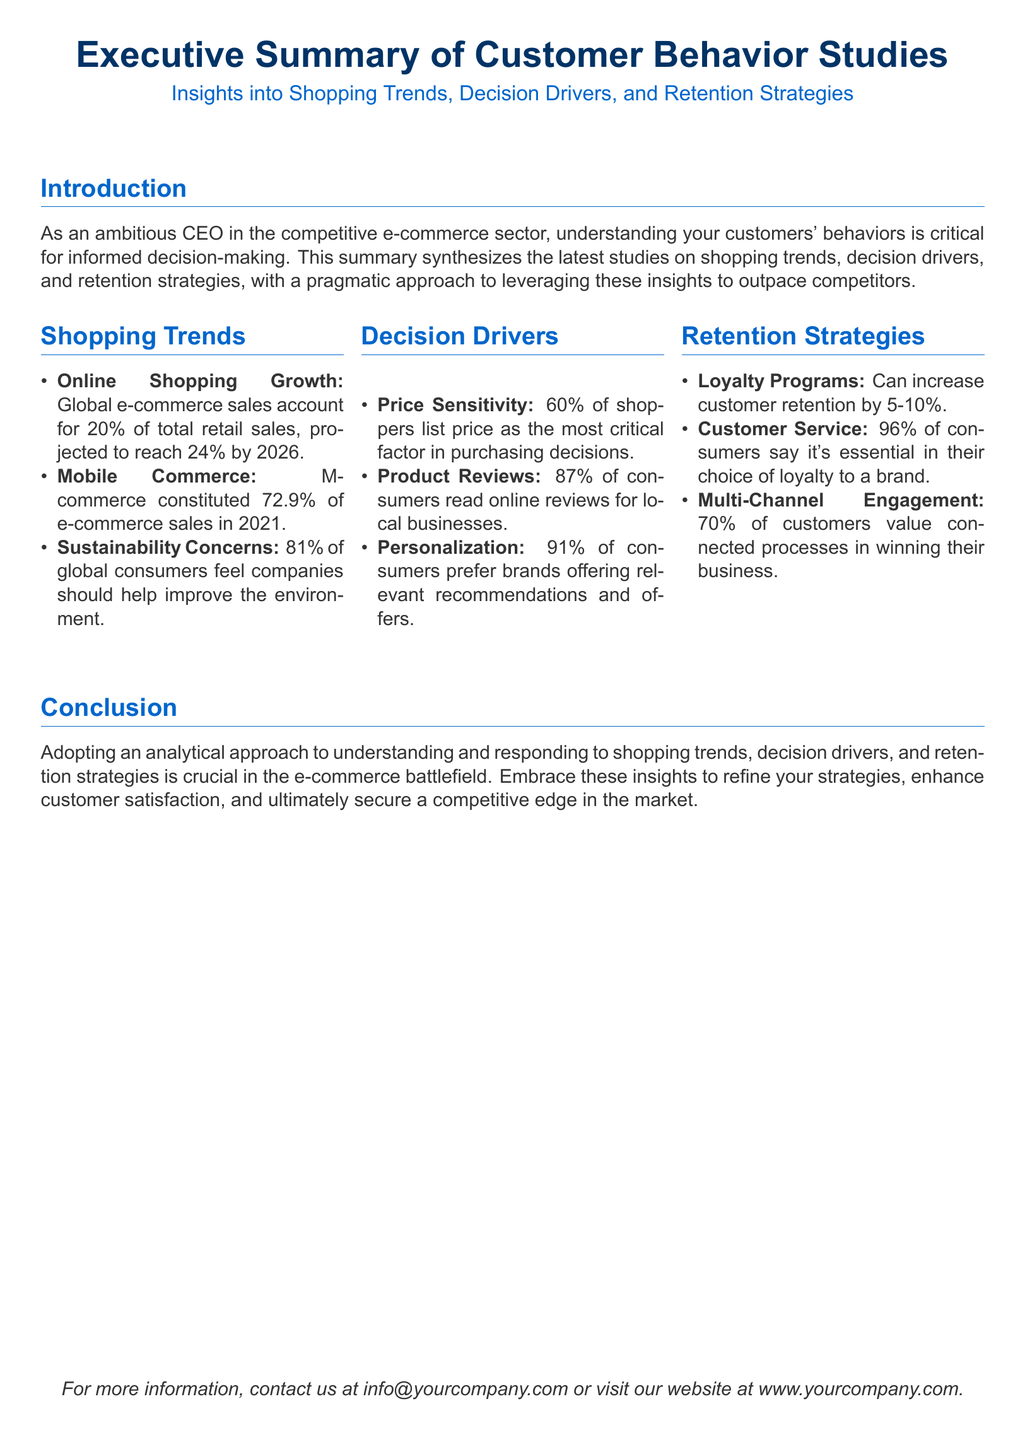What percentage of global consumers feel companies should help improve the environment? The document states that 81% of global consumers believe that companies should assist in environmental improvement.
Answer: 81% What is the projected percentage of global e-commerce sales by 2026? According to the document, global e-commerce sales are projected to reach 24% of total retail sales by 2026.
Answer: 24% What is the most critical factor in purchasing decisions for 60% of shoppers? The summary highlights that price is the most critical factor in purchasing decisions for 60% of shoppers.
Answer: Price What percentage of consumers prefer brands offering relevant recommendations? The document mentions that 91% of consumers prefer brands that provide tailored recommendations and offers.
Answer: 91% How much can loyalty programs increase customer retention? The document states that loyalty programs can increase customer retention by 5-10%.
Answer: 5-10% What is essential in the choice of loyalty to a brand for 96% of consumers? Customer service is noted as essential in the loyalty choice for 96% of consumers.
Answer: Customer service What shopping trend constituted 72.9% of e-commerce sales in 2021? The document states that mobile commerce comprised 72.9% of e-commerce sales in 2021.
Answer: Mobile commerce What is one of the key strategies to enhance customer satisfaction? The summary suggests adopting an analytical approach for refining strategies is a key tactic for enhancing customer satisfaction.
Answer: Analytical approach 